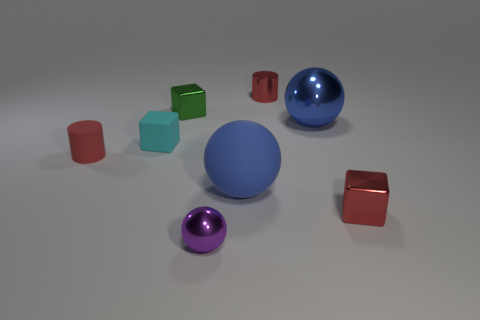Subtract all purple cylinders. How many blue balls are left? 2 Subtract all shiny spheres. How many spheres are left? 1 Add 2 small cylinders. How many objects exist? 10 Subtract all spheres. How many objects are left? 5 Subtract all yellow balls. Subtract all yellow blocks. How many balls are left? 3 Subtract all small red cubes. Subtract all red metallic things. How many objects are left? 5 Add 6 red metal objects. How many red metal objects are left? 8 Add 7 tiny yellow shiny things. How many tiny yellow shiny things exist? 7 Subtract 1 red blocks. How many objects are left? 7 